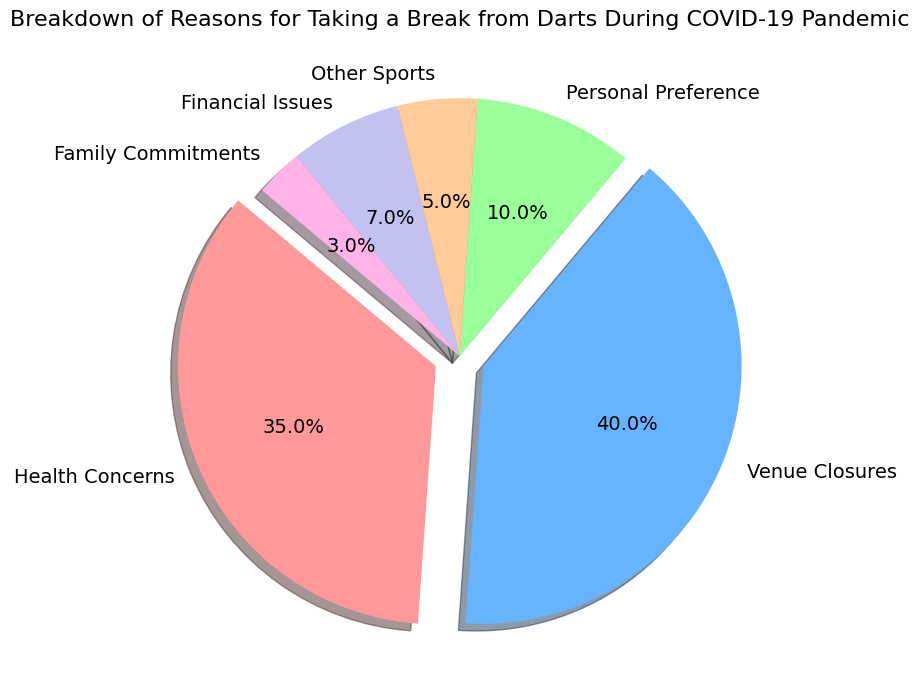What is the most common reason for taking a break from darts during the COVID-19 pandemic? The figure shows a pie chart breakdown of reasons with their percentages. The largest section is clearly marked for 'Venue Closures'.
Answer: Venue Closures Which reason has a smaller percentage: Family Commitments or Financial Issues? The percentages for Family Commitments and Financial Issues are shown as 3% and 7% respectively. By comparing these, Family Commitments have a smaller percentage.
Answer: Family Commitments By how much does the percentage of Health Concerns exceed Personal Preference? The percentage for Health Concerns is 35%, and for Personal Preference it is 10%. The difference is calculated as 35% - 10%.
Answer: 25% What is the combined percentage of reasons other than Venue Closures and Health Concerns? First, identify the percentages of reasons other than Venue Closures and Health Concerns: Personal Preference (10%), Other Sports (5%), Financial Issues (7%), and Family Commitments (3%). Sum these values: 10% + 5% + 7% + 3% = 25%.
Answer: 25% Which reason is represented by the green slice in the pie chart? The pie chart uses specific colors for each category. The green slice is associated with 'Other Sports'.
Answer: Other Sports How does the percentage of Health Concerns compare to the sum of Financial Issues and Family Commitments? Health Concerns is 35%. Financial Issues and Family Commitments are 7% and 3% respectively. Their sum is 7% + 3% = 10%. Comparing the two, 35% is greater than 10%.
Answer: Health Concerns is greater What is the difference between the largest and smallest percentages in the pie chart? The largest percentage is 'Venue Closures' with 40%, and the smallest is 'Family Commitments' with 3%. The difference is 40% - 3%.
Answer: 37% Are the total percentages of Health Concerns and Personal Preference greater or less than 50%? The percentage for Health Concerns is 35% and Personal Preference is 10%. Their sum is 35% + 10%, resulting in 45%. Comparing to 50%, it is less.
Answer: Less than 50% Which two reasons hold the smallest portions of the pie chart? The pie chart shows percentages for each reason. The smallest portions are for Family Commitments (3%) and Other Sports (5%).
Answer: Family Commitments and Other Sports 